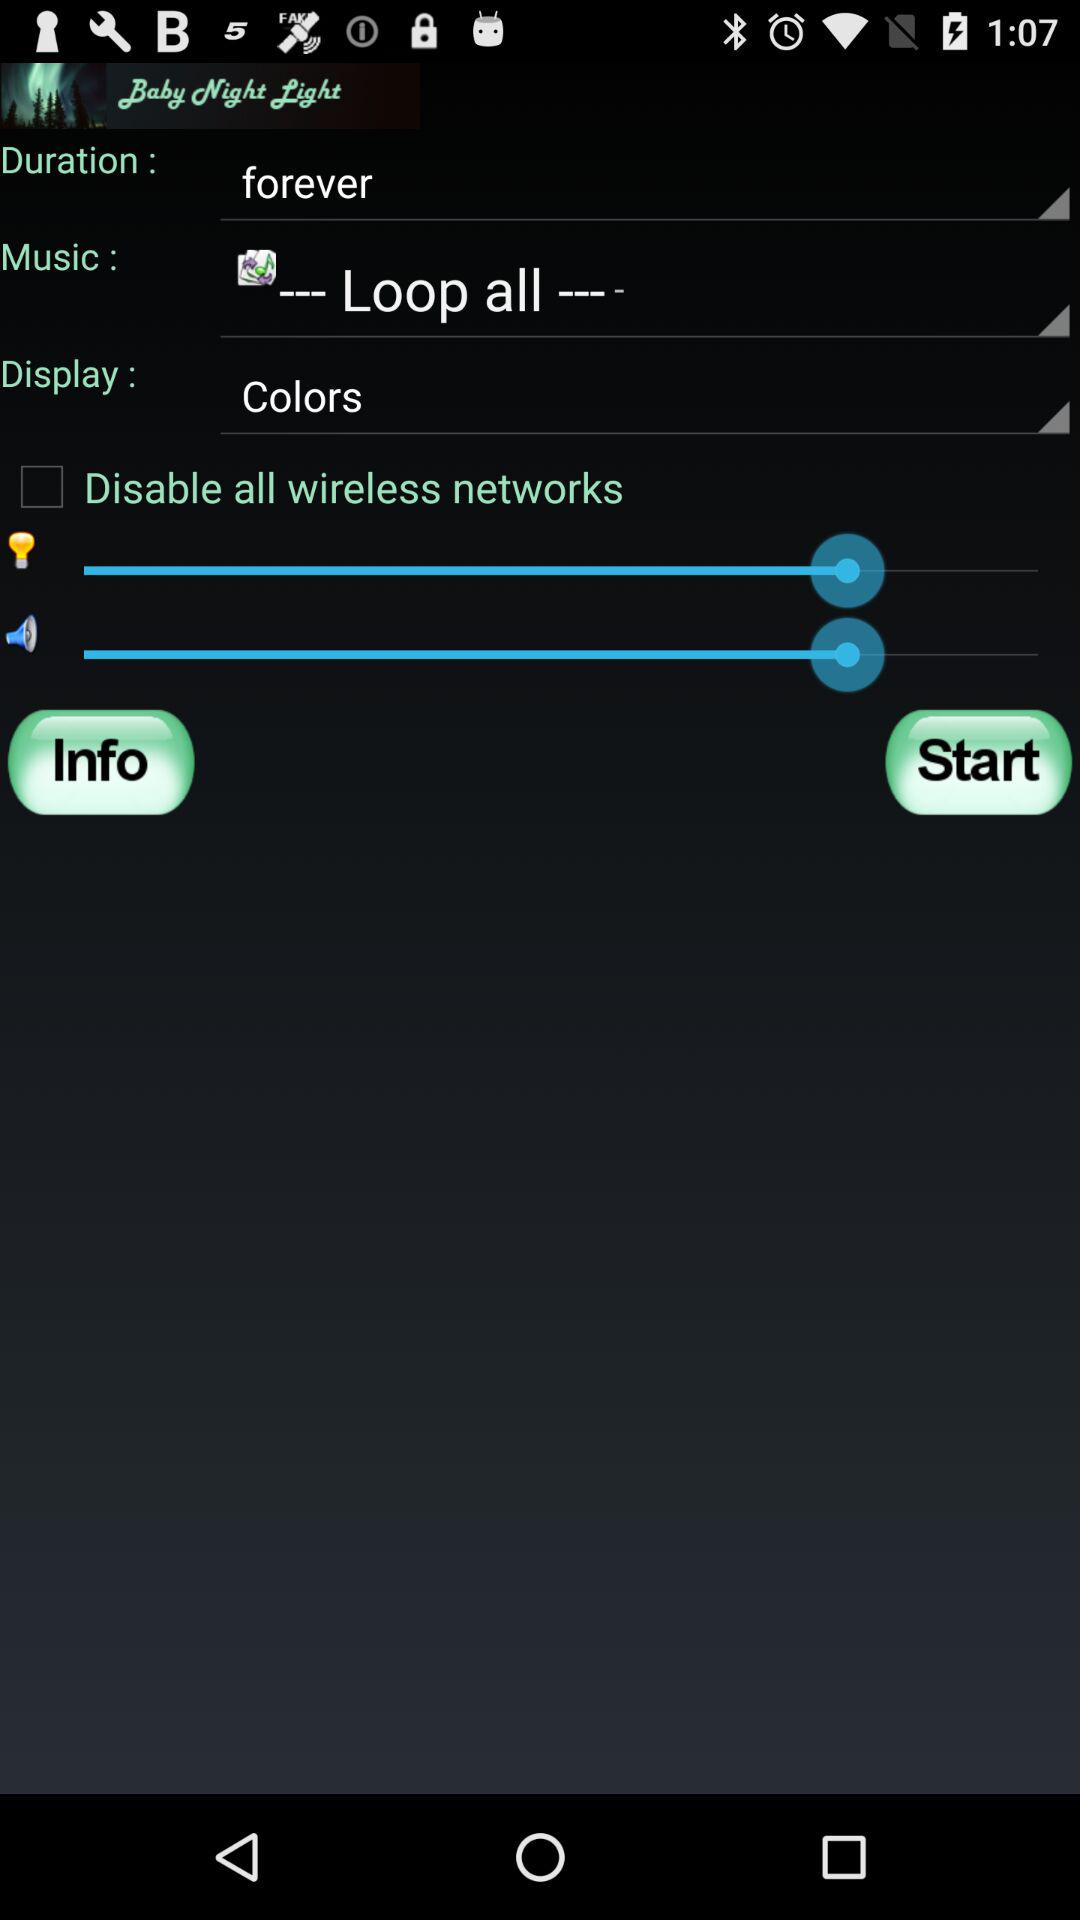What is the status of "Disable all wireless networks"? The status is "off". 